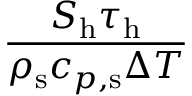Convert formula to latex. <formula><loc_0><loc_0><loc_500><loc_500>\frac { S _ { h } \tau _ { h } } { \rho _ { s } c _ { p , s } \Delta T }</formula> 